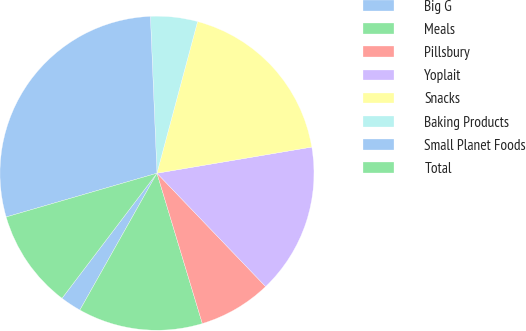<chart> <loc_0><loc_0><loc_500><loc_500><pie_chart><fcel>Big G<fcel>Meals<fcel>Pillsbury<fcel>Yoplait<fcel>Snacks<fcel>Baking Products<fcel>Small Planet Foods<fcel>Total<nl><fcel>2.17%<fcel>12.83%<fcel>7.5%<fcel>15.5%<fcel>18.17%<fcel>4.83%<fcel>28.83%<fcel>10.17%<nl></chart> 